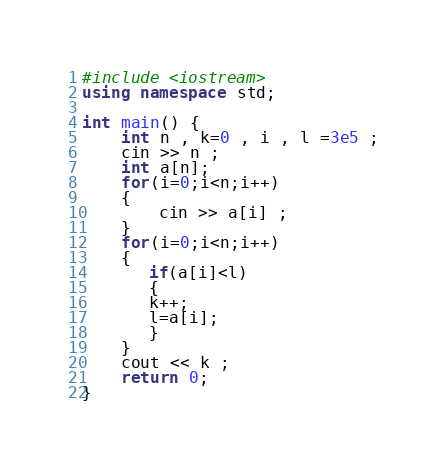<code> <loc_0><loc_0><loc_500><loc_500><_C++_>#include <iostream>
using namespace std;

int main() {
	int n , k=0 , i , l =3e5 ;
	cin >> n ;
	int a[n];
	for(i=0;i<n;i++)
	{
		cin >> a[i] ;
	}
	for(i=0;i<n;i++)
	{
	   if(a[i]<l)
	   {
	   k++;
	   l=a[i];
	   }
	}
	cout << k ;
	return 0;
}</code> 